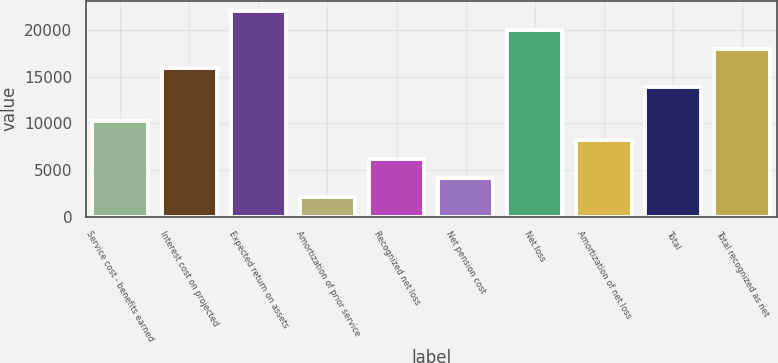<chart> <loc_0><loc_0><loc_500><loc_500><bar_chart><fcel>Service cost - benefits earned<fcel>Interest cost on projected<fcel>Expected return on assets<fcel>Amortization of prior service<fcel>Recognized net loss<fcel>Net pension cost<fcel>Net loss<fcel>Amortization of net loss<fcel>Total<fcel>Total recognized as net<nl><fcel>10307<fcel>15919.4<fcel>22064.6<fcel>2113.4<fcel>6210.2<fcel>4161.8<fcel>20016.2<fcel>8258.6<fcel>13871<fcel>17967.8<nl></chart> 